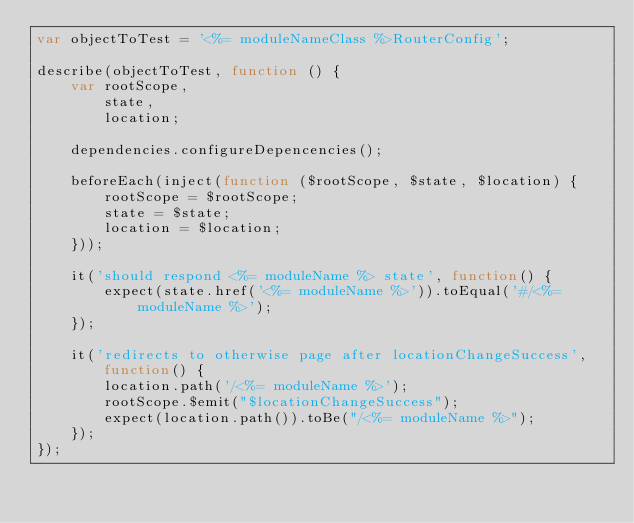Convert code to text. <code><loc_0><loc_0><loc_500><loc_500><_JavaScript_>var objectToTest = '<%= moduleNameClass %>RouterConfig';

describe(objectToTest, function () {
    var rootScope,
        state,
        location;

    dependencies.configureDepencencies();

    beforeEach(inject(function ($rootScope, $state, $location) {
        rootScope = $rootScope;
        state = $state;
        location = $location;
    }));

    it('should respond <%= moduleName %> state', function() {
        expect(state.href('<%= moduleName %>')).toEqual('#/<%= moduleName %>');
    });

    it('redirects to otherwise page after locationChangeSuccess', function() {
        location.path('/<%= moduleName %>');
        rootScope.$emit("$locationChangeSuccess");
        expect(location.path()).toBe("/<%= moduleName %>");
    });
});
</code> 